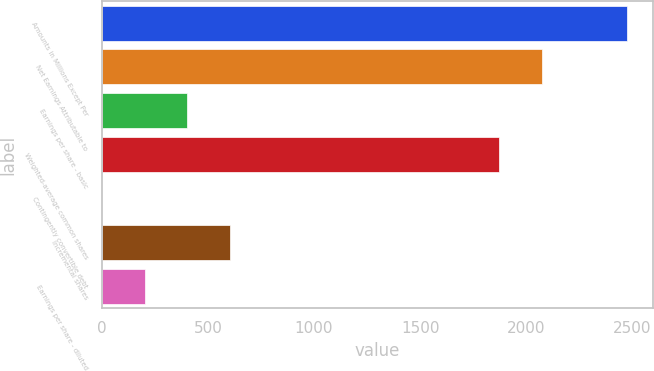Convert chart. <chart><loc_0><loc_0><loc_500><loc_500><bar_chart><fcel>Amounts in Millions Except Per<fcel>Net Earnings Attributable to<fcel>Earnings per share - basic<fcel>Weighted-average common shares<fcel>Contingently convertible debt<fcel>Incremental shares<fcel>Earnings per share - diluted<nl><fcel>2474.4<fcel>2072.2<fcel>403.2<fcel>1871.1<fcel>1<fcel>604.3<fcel>202.1<nl></chart> 